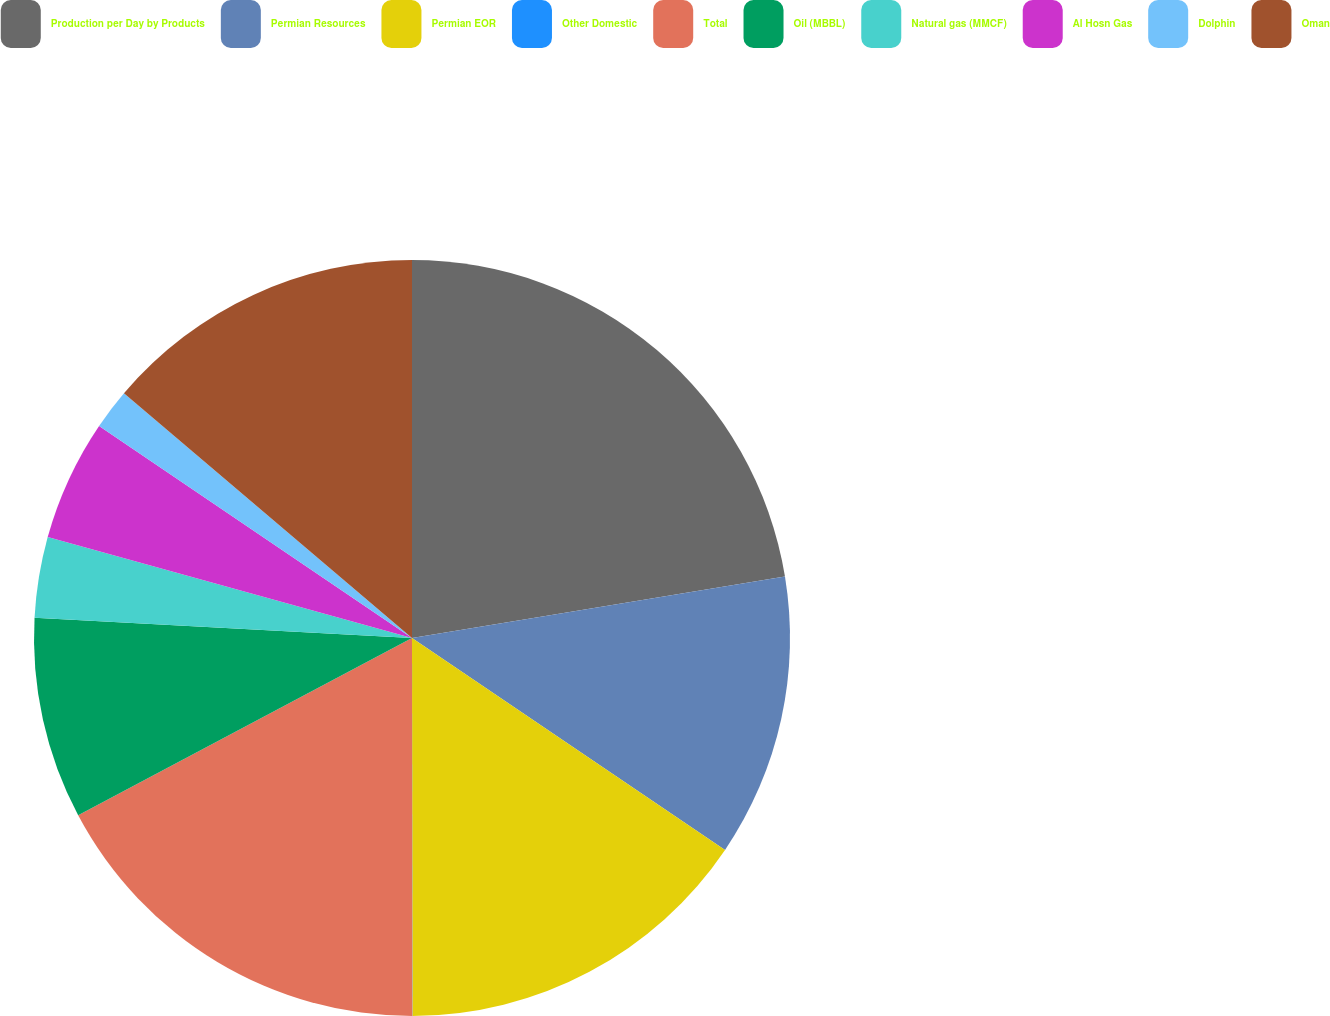<chart> <loc_0><loc_0><loc_500><loc_500><pie_chart><fcel>Production per Day by Products<fcel>Permian Resources<fcel>Permian EOR<fcel>Other Domestic<fcel>Total<fcel>Oil (MBBL)<fcel>Natural gas (MMCF)<fcel>Al Hosn Gas<fcel>Dolphin<fcel>Oman<nl><fcel>22.4%<fcel>12.07%<fcel>15.51%<fcel>0.01%<fcel>17.24%<fcel>8.62%<fcel>3.45%<fcel>5.18%<fcel>1.73%<fcel>13.79%<nl></chart> 